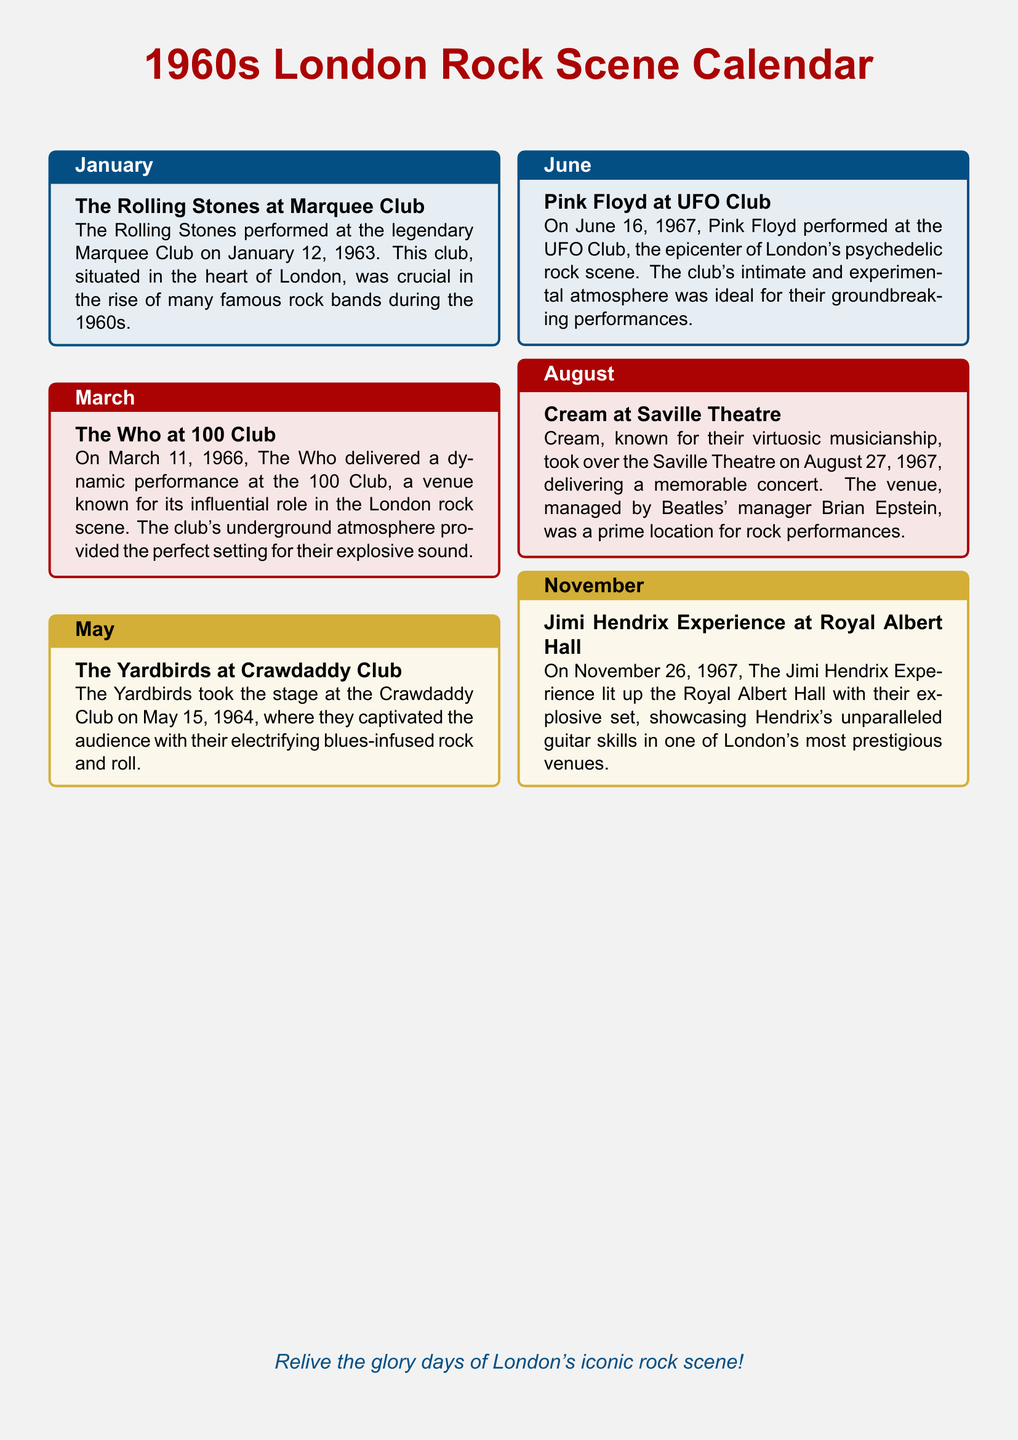what band performed at the Marquee Club? The document states that The Rolling Stones performed at the Marquee Club.
Answer: The Rolling Stones when did The Who perform at the 100 Club? The document specifies that The Who delivered a performance on March 11, 1966.
Answer: March 11, 1966 which venue hosted the Yardbirds' concert? According to the document, the Yardbirds took the stage at the Crawdaddy Club.
Answer: Crawdaddy Club what was the date of Pink Floyd's concert at the UFO Club? The document mentions that Pink Floyd performed on June 16, 1967.
Answer: June 16, 1967 who performed at the Royal Albert Hall in November? The document indicates that The Jimi Hendrix Experience lit up the Royal Albert Hall.
Answer: Jimi Hendrix Experience what genre did Cream represent at their concert? The document describes Cream as known for their virtuosic musicianship in rock music.
Answer: rock which month features a concert by Cream? The document states that Cream performed in August.
Answer: August what is the color theme of the January box? The document uses a blue color theme for the January box.
Answer: blue what type of performance was highlighted at the 100 Club? The document emphasizes The Who's dynamic performance at the 100 Club.
Answer: dynamic 